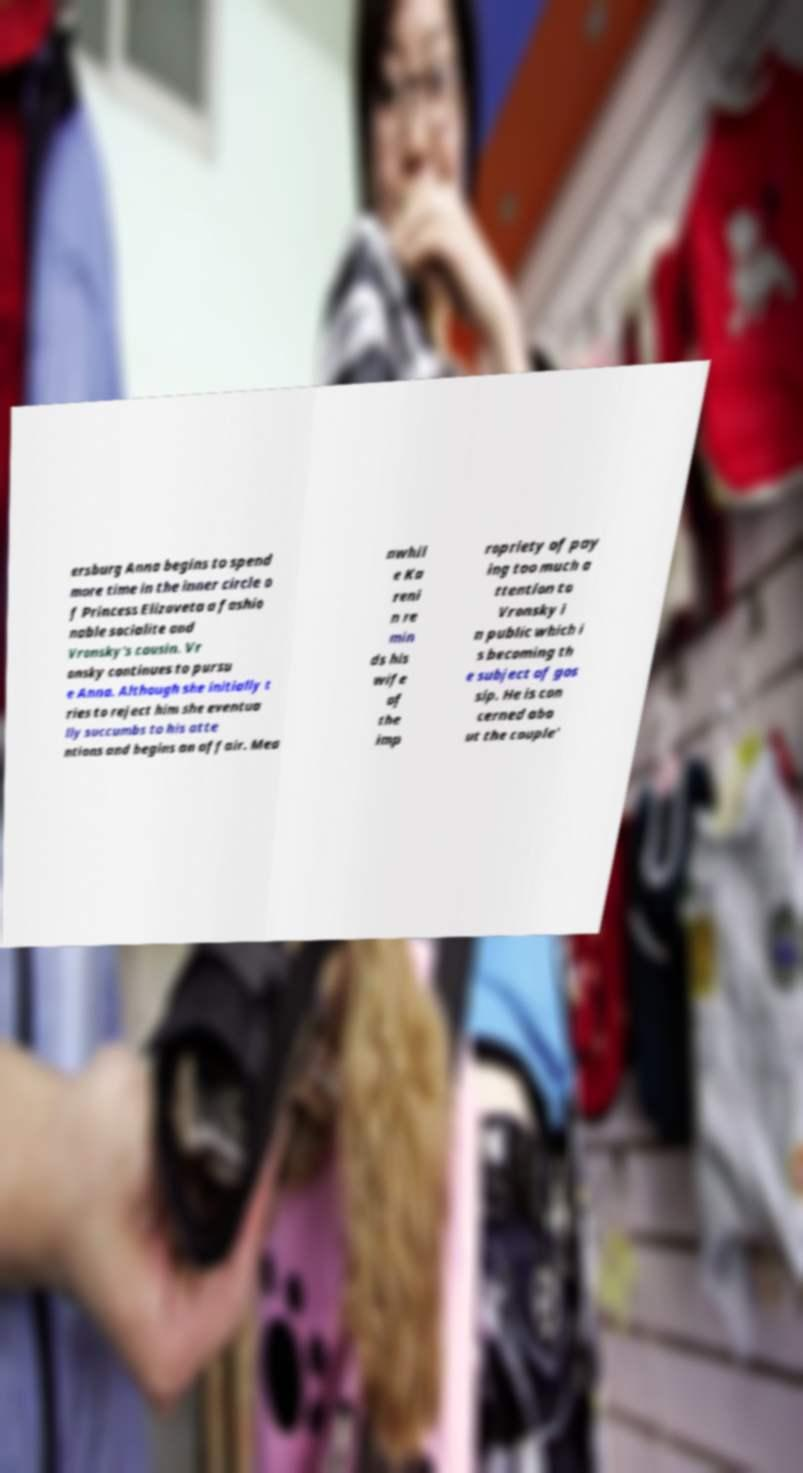There's text embedded in this image that I need extracted. Can you transcribe it verbatim? ersburg Anna begins to spend more time in the inner circle o f Princess Elizaveta a fashio nable socialite and Vronsky's cousin. Vr onsky continues to pursu e Anna. Although she initially t ries to reject him she eventua lly succumbs to his atte ntions and begins an affair. Mea nwhil e Ka reni n re min ds his wife of the imp ropriety of pay ing too much a ttention to Vronsky i n public which i s becoming th e subject of gos sip. He is con cerned abo ut the couple' 